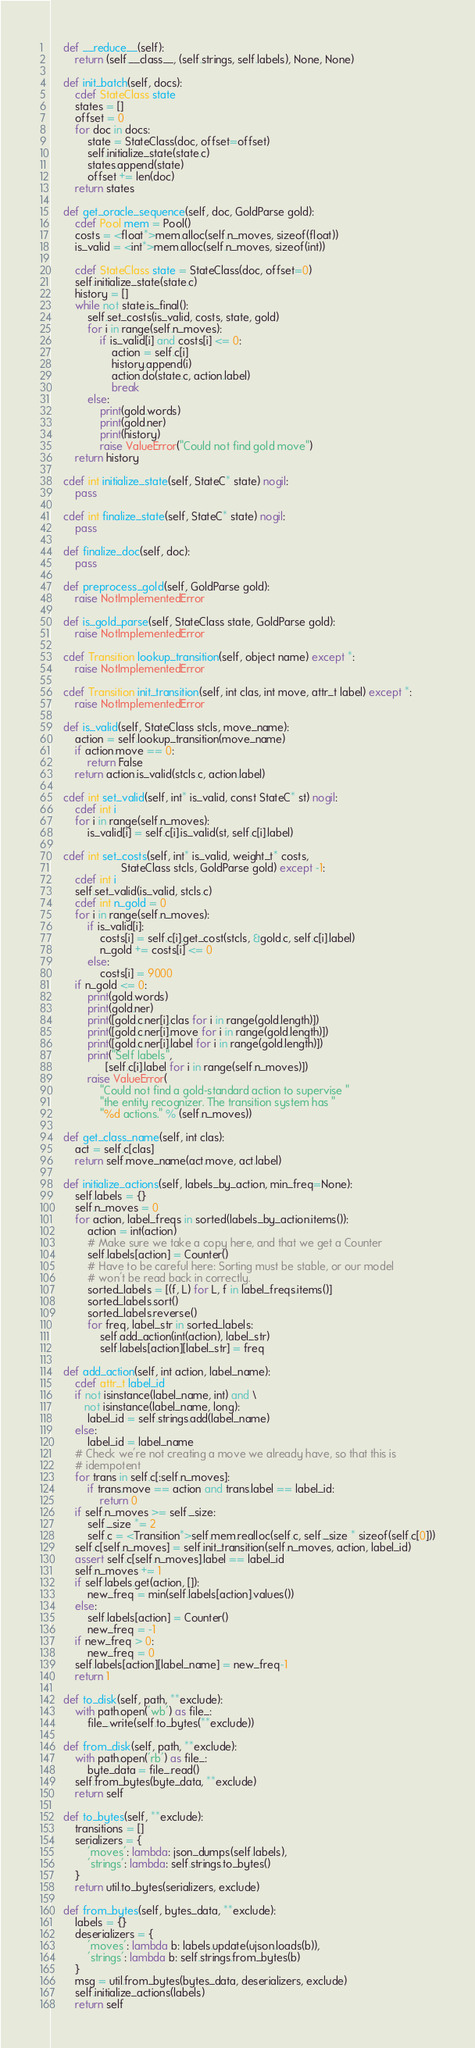<code> <loc_0><loc_0><loc_500><loc_500><_Cython_>
    def __reduce__(self):
        return (self.__class__, (self.strings, self.labels), None, None)

    def init_batch(self, docs):
        cdef StateClass state
        states = []
        offset = 0
        for doc in docs:
            state = StateClass(doc, offset=offset)
            self.initialize_state(state.c)
            states.append(state)
            offset += len(doc)
        return states

    def get_oracle_sequence(self, doc, GoldParse gold):
        cdef Pool mem = Pool()
        costs = <float*>mem.alloc(self.n_moves, sizeof(float))
        is_valid = <int*>mem.alloc(self.n_moves, sizeof(int))

        cdef StateClass state = StateClass(doc, offset=0)
        self.initialize_state(state.c)
        history = []
        while not state.is_final():
            self.set_costs(is_valid, costs, state, gold)
            for i in range(self.n_moves):
                if is_valid[i] and costs[i] <= 0:
                    action = self.c[i]
                    history.append(i)
                    action.do(state.c, action.label)
                    break
            else:
                print(gold.words)
                print(gold.ner)
                print(history)
                raise ValueError("Could not find gold move")
        return history

    cdef int initialize_state(self, StateC* state) nogil:
        pass

    cdef int finalize_state(self, StateC* state) nogil:
        pass

    def finalize_doc(self, doc):
        pass

    def preprocess_gold(self, GoldParse gold):
        raise NotImplementedError

    def is_gold_parse(self, StateClass state, GoldParse gold):
        raise NotImplementedError

    cdef Transition lookup_transition(self, object name) except *:
        raise NotImplementedError

    cdef Transition init_transition(self, int clas, int move, attr_t label) except *:
        raise NotImplementedError

    def is_valid(self, StateClass stcls, move_name):
        action = self.lookup_transition(move_name)
        if action.move == 0:
            return False
        return action.is_valid(stcls.c, action.label)

    cdef int set_valid(self, int* is_valid, const StateC* st) nogil:
        cdef int i
        for i in range(self.n_moves):
            is_valid[i] = self.c[i].is_valid(st, self.c[i].label)

    cdef int set_costs(self, int* is_valid, weight_t* costs,
                       StateClass stcls, GoldParse gold) except -1:
        cdef int i
        self.set_valid(is_valid, stcls.c)
        cdef int n_gold = 0
        for i in range(self.n_moves):
            if is_valid[i]:
                costs[i] = self.c[i].get_cost(stcls, &gold.c, self.c[i].label)
                n_gold += costs[i] <= 0
            else:
                costs[i] = 9000
        if n_gold <= 0:
            print(gold.words)
            print(gold.ner)
            print([gold.c.ner[i].clas for i in range(gold.length)])
            print([gold.c.ner[i].move for i in range(gold.length)])
            print([gold.c.ner[i].label for i in range(gold.length)])
            print("Self labels",
                  [self.c[i].label for i in range(self.n_moves)])
            raise ValueError(
                "Could not find a gold-standard action to supervise "
                "the entity recognizer. The transition system has "
                "%d actions." % (self.n_moves))

    def get_class_name(self, int clas):
        act = self.c[clas]
        return self.move_name(act.move, act.label)

    def initialize_actions(self, labels_by_action, min_freq=None):
        self.labels = {}
        self.n_moves = 0
        for action, label_freqs in sorted(labels_by_action.items()):
            action = int(action)
            # Make sure we take a copy here, and that we get a Counter
            self.labels[action] = Counter()
            # Have to be careful here: Sorting must be stable, or our model
            # won't be read back in correctly. 
            sorted_labels = [(f, L) for L, f in label_freqs.items()]
            sorted_labels.sort()
            sorted_labels.reverse()
            for freq, label_str in sorted_labels:
                self.add_action(int(action), label_str)
                self.labels[action][label_str] = freq 

    def add_action(self, int action, label_name):
        cdef attr_t label_id
        if not isinstance(label_name, int) and \
           not isinstance(label_name, long):
            label_id = self.strings.add(label_name)
        else:
            label_id = label_name
        # Check we're not creating a move we already have, so that this is
        # idempotent
        for trans in self.c[:self.n_moves]:
            if trans.move == action and trans.label == label_id:
                return 0
        if self.n_moves >= self._size:
            self._size *= 2
            self.c = <Transition*>self.mem.realloc(self.c, self._size * sizeof(self.c[0]))
        self.c[self.n_moves] = self.init_transition(self.n_moves, action, label_id)
        assert self.c[self.n_moves].label == label_id
        self.n_moves += 1
        if self.labels.get(action, []):
            new_freq = min(self.labels[action].values())
        else:
            self.labels[action] = Counter()
            new_freq = -1
        if new_freq > 0:
            new_freq = 0
        self.labels[action][label_name] = new_freq-1
        return 1

    def to_disk(self, path, **exclude):
        with path.open('wb') as file_:
            file_.write(self.to_bytes(**exclude))

    def from_disk(self, path, **exclude):
        with path.open('rb') as file_:
            byte_data = file_.read()
        self.from_bytes(byte_data, **exclude)
        return self

    def to_bytes(self, **exclude):
        transitions = []
        serializers = {
            'moves': lambda: json_dumps(self.labels),
            'strings': lambda: self.strings.to_bytes()
        }
        return util.to_bytes(serializers, exclude)

    def from_bytes(self, bytes_data, **exclude):
        labels = {}
        deserializers = {
            'moves': lambda b: labels.update(ujson.loads(b)),
            'strings': lambda b: self.strings.from_bytes(b)
        }
        msg = util.from_bytes(bytes_data, deserializers, exclude)
        self.initialize_actions(labels)
        return self
</code> 